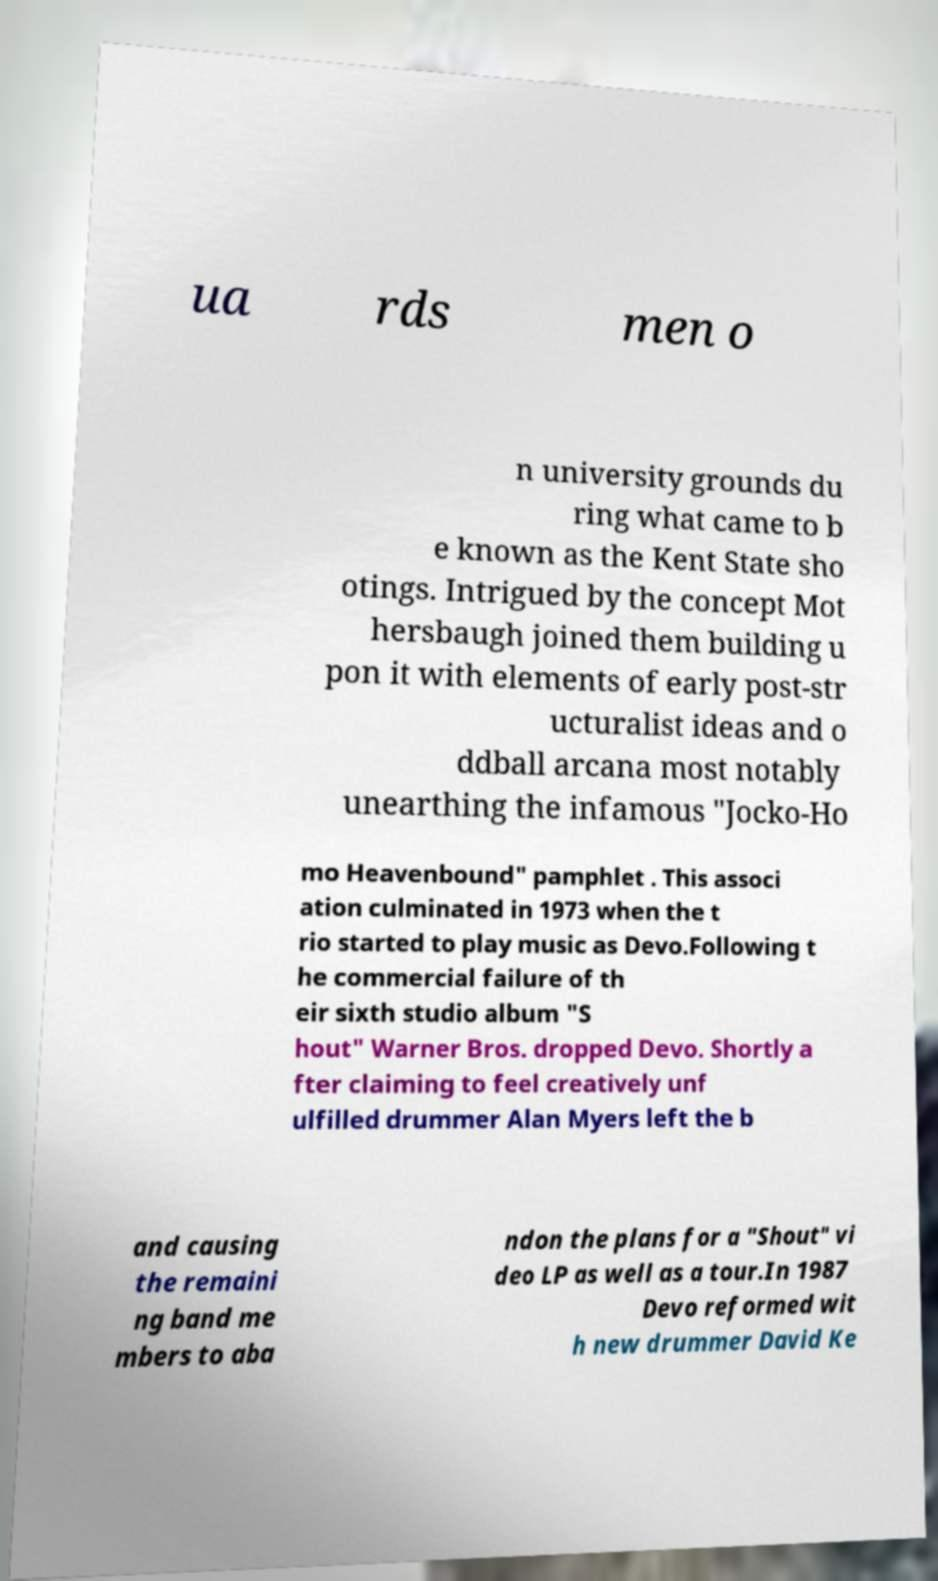For documentation purposes, I need the text within this image transcribed. Could you provide that? ua rds men o n university grounds du ring what came to b e known as the Kent State sho otings. Intrigued by the concept Mot hersbaugh joined them building u pon it with elements of early post-str ucturalist ideas and o ddball arcana most notably unearthing the infamous "Jocko-Ho mo Heavenbound" pamphlet . This associ ation culminated in 1973 when the t rio started to play music as Devo.Following t he commercial failure of th eir sixth studio album "S hout" Warner Bros. dropped Devo. Shortly a fter claiming to feel creatively unf ulfilled drummer Alan Myers left the b and causing the remaini ng band me mbers to aba ndon the plans for a "Shout" vi deo LP as well as a tour.In 1987 Devo reformed wit h new drummer David Ke 